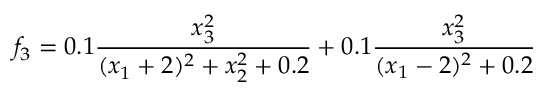<formula> <loc_0><loc_0><loc_500><loc_500>f _ { 3 } = 0 . 1 \frac { x _ { 3 } ^ { 2 } } { ( x _ { 1 } + 2 ) ^ { 2 } + x _ { 2 } ^ { 2 } + 0 . 2 } + 0 . 1 \frac { x _ { 3 } ^ { 2 } } { ( x _ { 1 } - 2 ) ^ { 2 } + 0 . 2 }</formula> 